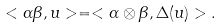Convert formula to latex. <formula><loc_0><loc_0><loc_500><loc_500>< \alpha \beta , u > = < \alpha \otimes \beta , \Delta ( u ) > .</formula> 